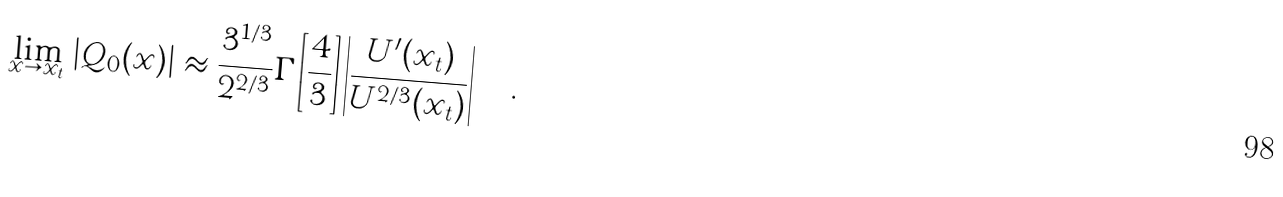<formula> <loc_0><loc_0><loc_500><loc_500>\lim _ { x \rightarrow x _ { t } } \left | Q _ { 0 } ( x ) \right | \approx \frac { 3 ^ { 1 / 3 } } { 2 ^ { 2 / 3 } } \Gamma \left [ \frac { 4 } { 3 } \right ] \left | \frac { U ^ { \prime } ( x _ { t } ) } { U ^ { 2 / 3 } ( x _ { t } ) } \right | \quad .</formula> 